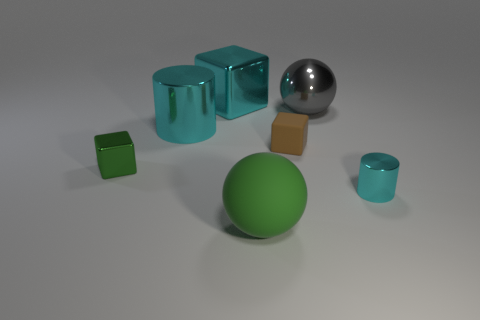Are the cyan object that is on the right side of the tiny brown matte cube and the thing in front of the small cyan cylinder made of the same material?
Your response must be concise. No. What is the size of the metallic block that is the same color as the small shiny cylinder?
Offer a very short reply. Large. There is a ball that is in front of the brown rubber object; what is it made of?
Your answer should be compact. Rubber. Do the cyan metallic object in front of the tiny matte thing and the tiny brown object on the left side of the big gray shiny object have the same shape?
Ensure brevity in your answer.  No. There is a large cylinder that is the same color as the large block; what is it made of?
Ensure brevity in your answer.  Metal. Are any cyan objects visible?
Ensure brevity in your answer.  Yes. There is a small green object that is the same shape as the brown thing; what is its material?
Offer a terse response. Metal. Are there any large shiny things behind the large cyan metal block?
Ensure brevity in your answer.  No. Is the material of the sphere that is in front of the tiny cyan cylinder the same as the big gray sphere?
Ensure brevity in your answer.  No. Are there any big rubber objects of the same color as the big cylinder?
Provide a short and direct response. No. 